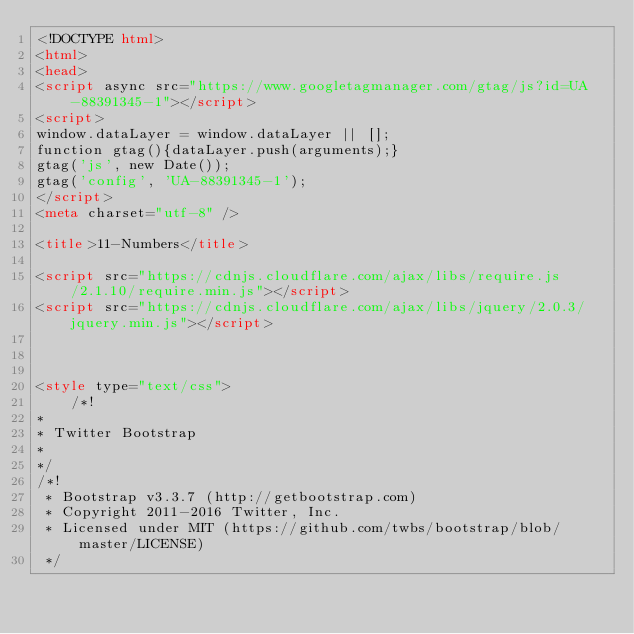Convert code to text. <code><loc_0><loc_0><loc_500><loc_500><_HTML_><!DOCTYPE html>
<html>
<head>
<script async src="https://www.googletagmanager.com/gtag/js?id=UA-88391345-1"></script>
<script>
window.dataLayer = window.dataLayer || [];
function gtag(){dataLayer.push(arguments);}
gtag('js', new Date());
gtag('config', 'UA-88391345-1');
</script>
<meta charset="utf-8" />

<title>11-Numbers</title>

<script src="https://cdnjs.cloudflare.com/ajax/libs/require.js/2.1.10/require.min.js"></script>
<script src="https://cdnjs.cloudflare.com/ajax/libs/jquery/2.0.3/jquery.min.js"></script>



<style type="text/css">
    /*!
*
* Twitter Bootstrap
*
*/
/*!
 * Bootstrap v3.3.7 (http://getbootstrap.com)
 * Copyright 2011-2016 Twitter, Inc.
 * Licensed under MIT (https://github.com/twbs/bootstrap/blob/master/LICENSE)
 */</code> 